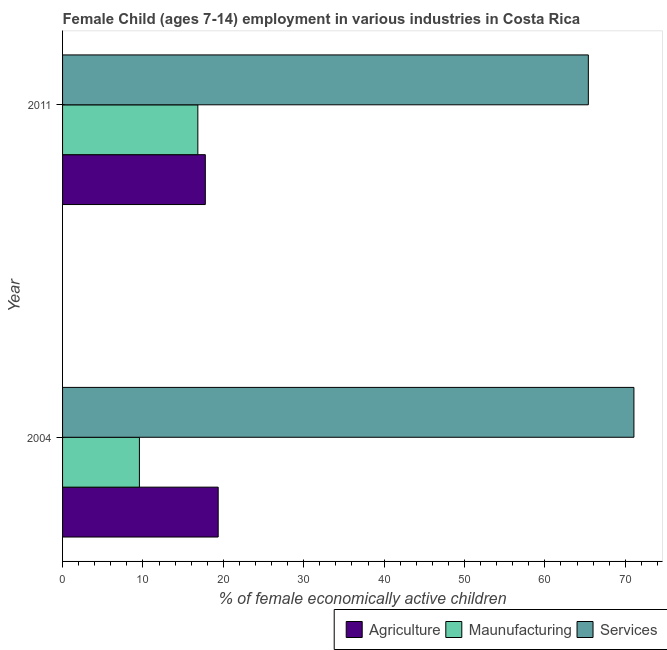How many different coloured bars are there?
Give a very brief answer. 3. How many bars are there on the 2nd tick from the bottom?
Ensure brevity in your answer.  3. What is the label of the 1st group of bars from the top?
Your response must be concise. 2011. What is the percentage of economically active children in agriculture in 2004?
Your response must be concise. 19.36. Across all years, what is the maximum percentage of economically active children in agriculture?
Your answer should be very brief. 19.36. Across all years, what is the minimum percentage of economically active children in manufacturing?
Provide a short and direct response. 9.56. In which year was the percentage of economically active children in services maximum?
Provide a short and direct response. 2004. In which year was the percentage of economically active children in services minimum?
Offer a terse response. 2011. What is the total percentage of economically active children in manufacturing in the graph?
Make the answer very short. 26.39. What is the difference between the percentage of economically active children in services in 2004 and that in 2011?
Make the answer very short. 5.67. What is the difference between the percentage of economically active children in services in 2004 and the percentage of economically active children in manufacturing in 2011?
Your response must be concise. 54.25. What is the average percentage of economically active children in manufacturing per year?
Give a very brief answer. 13.2. In the year 2011, what is the difference between the percentage of economically active children in services and percentage of economically active children in manufacturing?
Offer a very short reply. 48.58. In how many years, is the percentage of economically active children in agriculture greater than 56 %?
Offer a very short reply. 0. What is the ratio of the percentage of economically active children in manufacturing in 2004 to that in 2011?
Your response must be concise. 0.57. Is the difference between the percentage of economically active children in agriculture in 2004 and 2011 greater than the difference between the percentage of economically active children in manufacturing in 2004 and 2011?
Keep it short and to the point. Yes. In how many years, is the percentage of economically active children in services greater than the average percentage of economically active children in services taken over all years?
Make the answer very short. 1. What does the 3rd bar from the top in 2004 represents?
Provide a succinct answer. Agriculture. What does the 3rd bar from the bottom in 2004 represents?
Ensure brevity in your answer.  Services. Is it the case that in every year, the sum of the percentage of economically active children in agriculture and percentage of economically active children in manufacturing is greater than the percentage of economically active children in services?
Your answer should be very brief. No. How many bars are there?
Ensure brevity in your answer.  6. Are all the bars in the graph horizontal?
Provide a succinct answer. Yes. How many years are there in the graph?
Give a very brief answer. 2. What is the difference between two consecutive major ticks on the X-axis?
Provide a succinct answer. 10. How many legend labels are there?
Your response must be concise. 3. What is the title of the graph?
Keep it short and to the point. Female Child (ages 7-14) employment in various industries in Costa Rica. What is the label or title of the X-axis?
Offer a terse response. % of female economically active children. What is the % of female economically active children of Agriculture in 2004?
Make the answer very short. 19.36. What is the % of female economically active children in Maunufacturing in 2004?
Your answer should be compact. 9.56. What is the % of female economically active children of Services in 2004?
Keep it short and to the point. 71.08. What is the % of female economically active children of Agriculture in 2011?
Keep it short and to the point. 17.76. What is the % of female economically active children of Maunufacturing in 2011?
Offer a very short reply. 16.83. What is the % of female economically active children of Services in 2011?
Give a very brief answer. 65.41. Across all years, what is the maximum % of female economically active children in Agriculture?
Provide a succinct answer. 19.36. Across all years, what is the maximum % of female economically active children of Maunufacturing?
Offer a terse response. 16.83. Across all years, what is the maximum % of female economically active children in Services?
Offer a very short reply. 71.08. Across all years, what is the minimum % of female economically active children of Agriculture?
Make the answer very short. 17.76. Across all years, what is the minimum % of female economically active children in Maunufacturing?
Provide a short and direct response. 9.56. Across all years, what is the minimum % of female economically active children of Services?
Make the answer very short. 65.41. What is the total % of female economically active children in Agriculture in the graph?
Offer a very short reply. 37.12. What is the total % of female economically active children in Maunufacturing in the graph?
Provide a succinct answer. 26.39. What is the total % of female economically active children of Services in the graph?
Your response must be concise. 136.49. What is the difference between the % of female economically active children of Maunufacturing in 2004 and that in 2011?
Your answer should be very brief. -7.27. What is the difference between the % of female economically active children in Services in 2004 and that in 2011?
Your answer should be compact. 5.67. What is the difference between the % of female economically active children in Agriculture in 2004 and the % of female economically active children in Maunufacturing in 2011?
Offer a very short reply. 2.53. What is the difference between the % of female economically active children in Agriculture in 2004 and the % of female economically active children in Services in 2011?
Ensure brevity in your answer.  -46.05. What is the difference between the % of female economically active children of Maunufacturing in 2004 and the % of female economically active children of Services in 2011?
Give a very brief answer. -55.85. What is the average % of female economically active children in Agriculture per year?
Your response must be concise. 18.56. What is the average % of female economically active children in Maunufacturing per year?
Give a very brief answer. 13.2. What is the average % of female economically active children of Services per year?
Ensure brevity in your answer.  68.25. In the year 2004, what is the difference between the % of female economically active children in Agriculture and % of female economically active children in Maunufacturing?
Ensure brevity in your answer.  9.8. In the year 2004, what is the difference between the % of female economically active children of Agriculture and % of female economically active children of Services?
Provide a short and direct response. -51.72. In the year 2004, what is the difference between the % of female economically active children of Maunufacturing and % of female economically active children of Services?
Make the answer very short. -61.52. In the year 2011, what is the difference between the % of female economically active children in Agriculture and % of female economically active children in Services?
Your response must be concise. -47.65. In the year 2011, what is the difference between the % of female economically active children in Maunufacturing and % of female economically active children in Services?
Your answer should be very brief. -48.58. What is the ratio of the % of female economically active children of Agriculture in 2004 to that in 2011?
Offer a very short reply. 1.09. What is the ratio of the % of female economically active children of Maunufacturing in 2004 to that in 2011?
Your response must be concise. 0.57. What is the ratio of the % of female economically active children of Services in 2004 to that in 2011?
Your answer should be compact. 1.09. What is the difference between the highest and the second highest % of female economically active children in Maunufacturing?
Give a very brief answer. 7.27. What is the difference between the highest and the second highest % of female economically active children in Services?
Make the answer very short. 5.67. What is the difference between the highest and the lowest % of female economically active children of Maunufacturing?
Your response must be concise. 7.27. What is the difference between the highest and the lowest % of female economically active children of Services?
Ensure brevity in your answer.  5.67. 